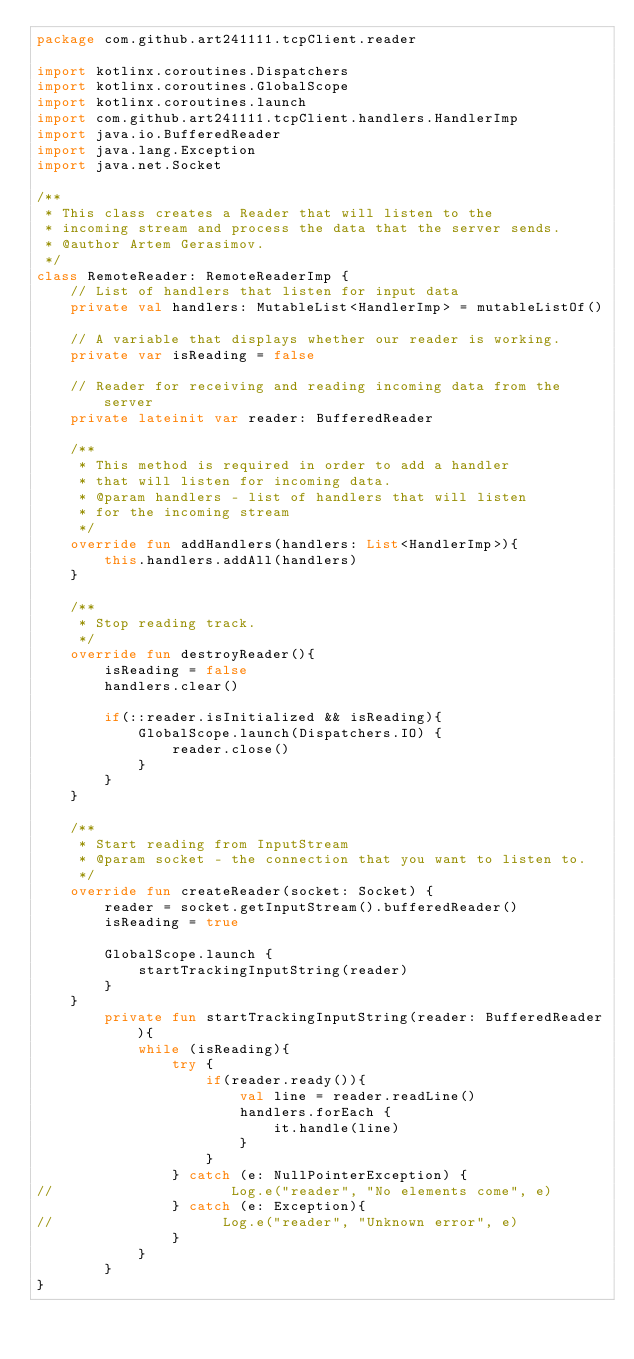<code> <loc_0><loc_0><loc_500><loc_500><_Kotlin_>package com.github.art241111.tcpClient.reader

import kotlinx.coroutines.Dispatchers
import kotlinx.coroutines.GlobalScope
import kotlinx.coroutines.launch
import com.github.art241111.tcpClient.handlers.HandlerImp
import java.io.BufferedReader
import java.lang.Exception
import java.net.Socket

/**
 * This class creates a Reader that will listen to the
 * incoming stream and process the data that the server sends.
 * @author Artem Gerasimov.
 */
class RemoteReader: RemoteReaderImp {
    // List of handlers that listen for input data
    private val handlers: MutableList<HandlerImp> = mutableListOf()

    // A variable that displays whether our reader is working.
    private var isReading = false

    // Reader for receiving and reading incoming data from the server
    private lateinit var reader: BufferedReader

    /**
     * This method is required in order to add a handler
     * that will listen for incoming data.
     * @param handlers - list of handlers that will listen
     * for the incoming stream
     */
    override fun addHandlers(handlers: List<HandlerImp>){
        this.handlers.addAll(handlers)
    }

    /**
     * Stop reading track.
     */
    override fun destroyReader(){
        isReading = false
        handlers.clear()

        if(::reader.isInitialized && isReading){
            GlobalScope.launch(Dispatchers.IO) {
                reader.close()
            }
        }
    }

    /**
     * Start reading from InputStream
     * @param socket - the connection that you want to listen to.
     */
    override fun createReader(socket: Socket) {
        reader = socket.getInputStream().bufferedReader()
        isReading = true

        GlobalScope.launch {
            startTrackingInputString(reader)
        }
    }
        private fun startTrackingInputString(reader: BufferedReader){
            while (isReading){
                try {
                    if(reader.ready()){
                        val line = reader.readLine()
                        handlers.forEach {
                            it.handle(line)
                        }
                    }
                } catch (e: NullPointerException) {
//                     Log.e("reader", "No elements come", e)
                } catch (e: Exception){
//                    Log.e("reader", "Unknown error", e)
                }
            }
        }
}
</code> 